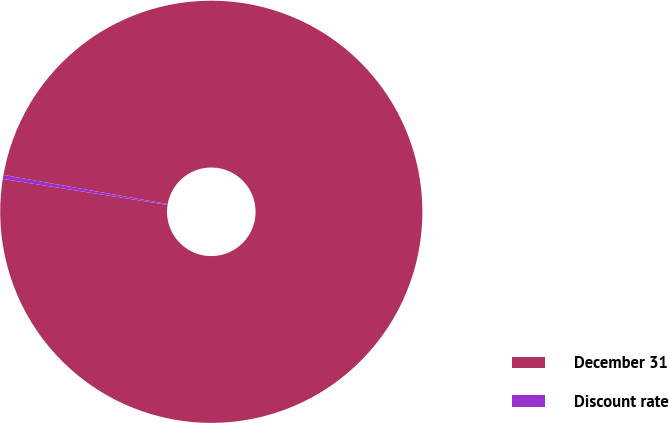Convert chart. <chart><loc_0><loc_0><loc_500><loc_500><pie_chart><fcel>December 31<fcel>Discount rate<nl><fcel>99.69%<fcel>0.31%<nl></chart> 